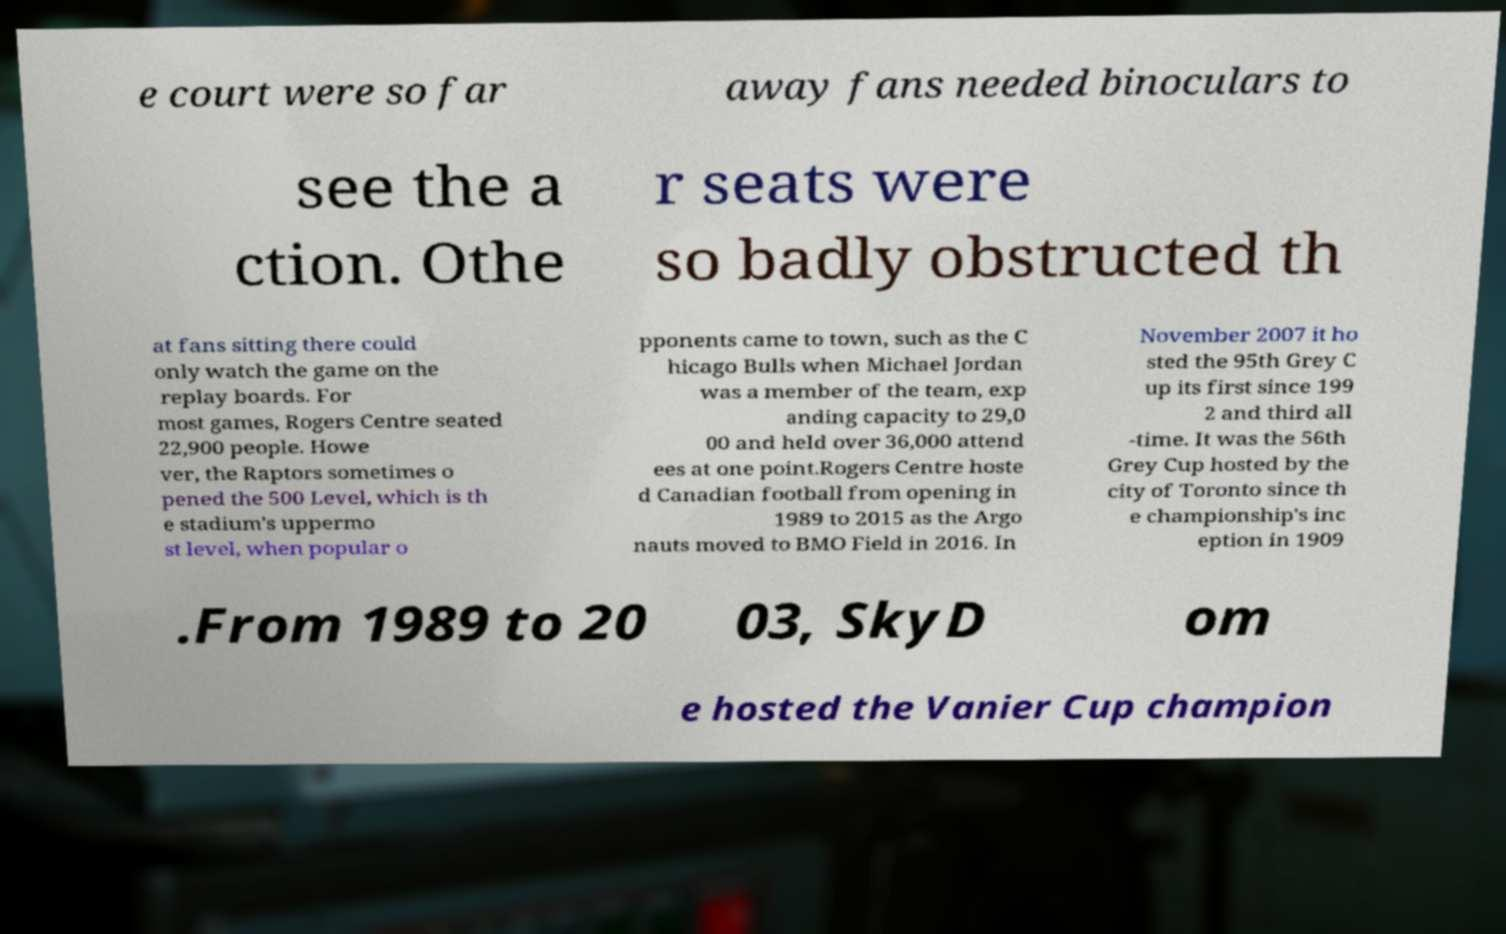For documentation purposes, I need the text within this image transcribed. Could you provide that? e court were so far away fans needed binoculars to see the a ction. Othe r seats were so badly obstructed th at fans sitting there could only watch the game on the replay boards. For most games, Rogers Centre seated 22,900 people. Howe ver, the Raptors sometimes o pened the 500 Level, which is th e stadium's uppermo st level, when popular o pponents came to town, such as the C hicago Bulls when Michael Jordan was a member of the team, exp anding capacity to 29,0 00 and held over 36,000 attend ees at one point.Rogers Centre hoste d Canadian football from opening in 1989 to 2015 as the Argo nauts moved to BMO Field in 2016. In November 2007 it ho sted the 95th Grey C up its first since 199 2 and third all -time. It was the 56th Grey Cup hosted by the city of Toronto since th e championship's inc eption in 1909 .From 1989 to 20 03, SkyD om e hosted the Vanier Cup champion 